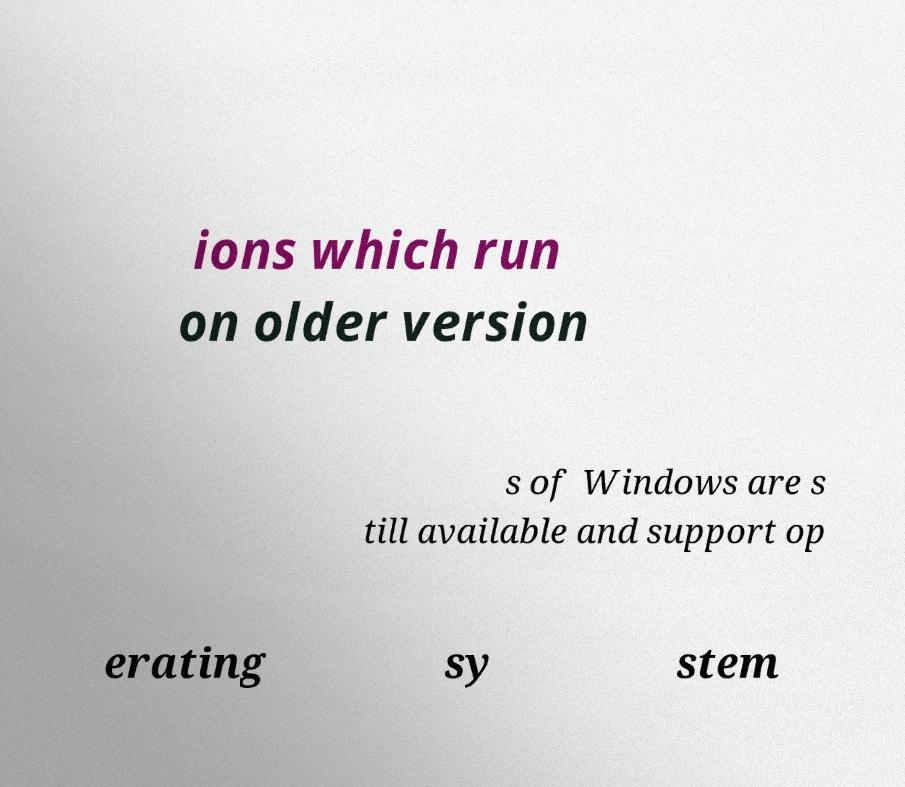What messages or text are displayed in this image? I need them in a readable, typed format. ions which run on older version s of Windows are s till available and support op erating sy stem 